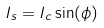<formula> <loc_0><loc_0><loc_500><loc_500>I _ { s } = I _ { c } \sin ( \phi )</formula> 